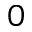Convert formula to latex. <formula><loc_0><loc_0><loc_500><loc_500>0</formula> 